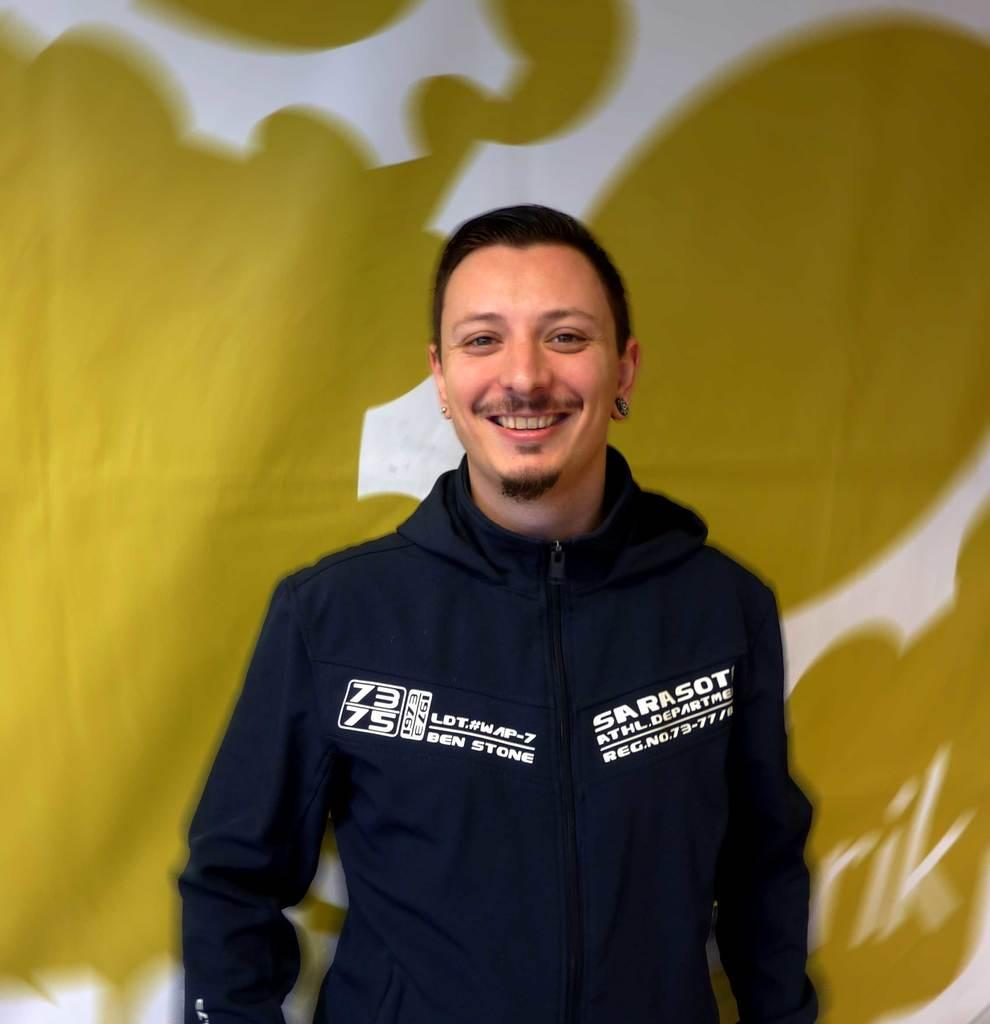<image>
Share a concise interpretation of the image provided. A man has a shirt with the name Ben Stone on the front. 